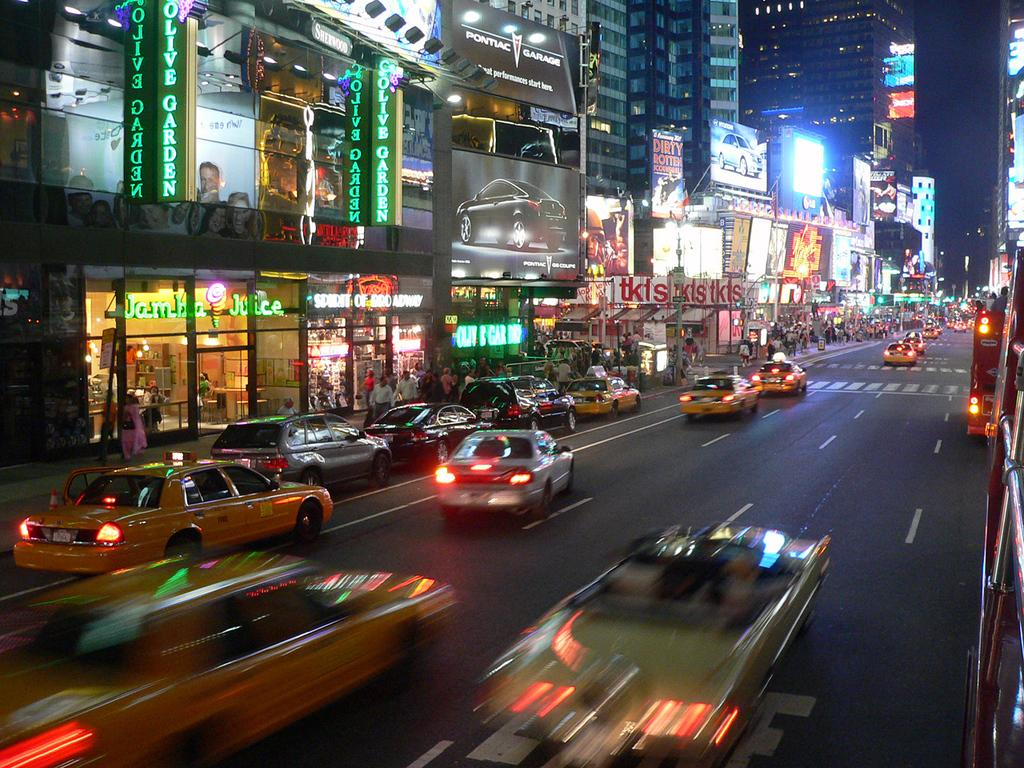Provide a one-sentence caption for the provided image. a busy city street with an olive garden restaurant on the corner. 